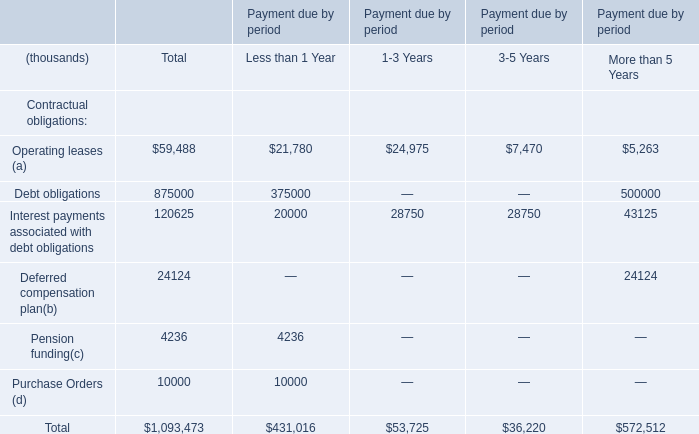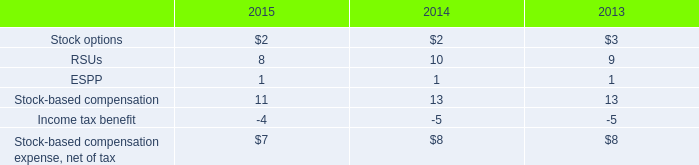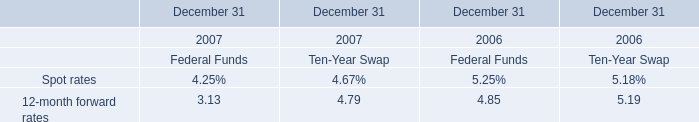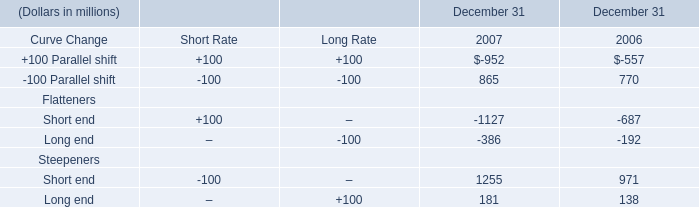What's the average of Flatteners Short end and Flatteners Long end and Steepeners Short end in 2007? (in million) 
Computations: (((-1127 - 386) + 1255) / 3)
Answer: -86.0. 